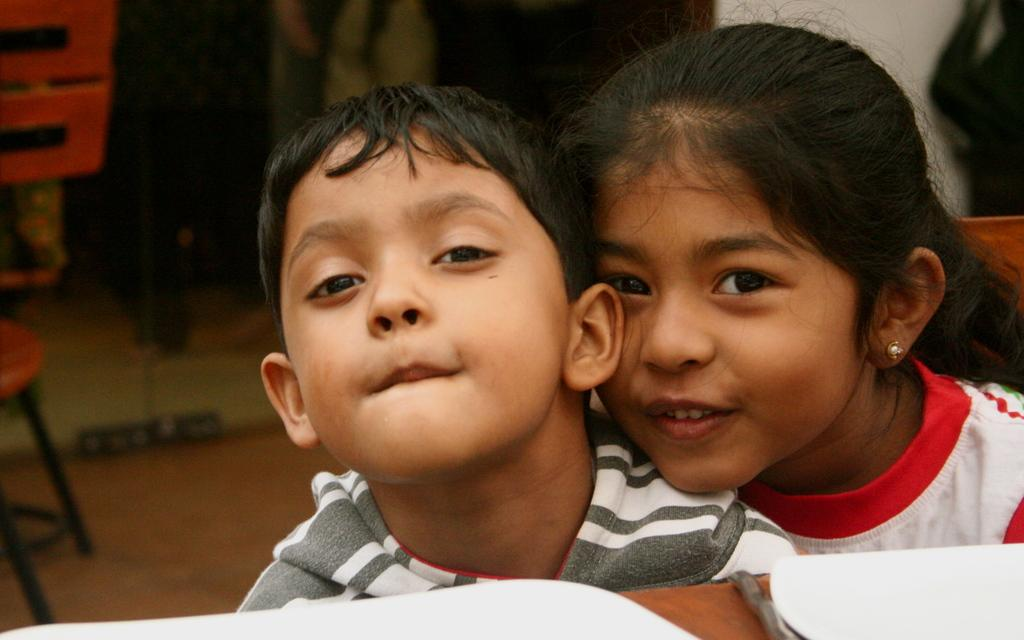What is the main subject in the center of the image? There are kids in the center of the image. What can be seen in the background of the image? There are chairs and some objects in the background of the image. What is the location of the wall in the image? There is a wall in the background of the image. What is the surface that the kids and chairs are standing on? There is a floor at the bottom of the image. What type of sugar is being discovered by the kids in the image? There is no sugar or discovery of sugar present in the image. Are the kids engaged in a fight in the image? There is no fight or any indication of conflict among the kids in the image. 